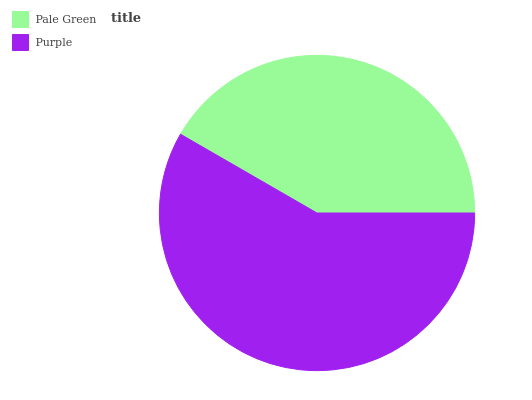Is Pale Green the minimum?
Answer yes or no. Yes. Is Purple the maximum?
Answer yes or no. Yes. Is Purple the minimum?
Answer yes or no. No. Is Purple greater than Pale Green?
Answer yes or no. Yes. Is Pale Green less than Purple?
Answer yes or no. Yes. Is Pale Green greater than Purple?
Answer yes or no. No. Is Purple less than Pale Green?
Answer yes or no. No. Is Purple the high median?
Answer yes or no. Yes. Is Pale Green the low median?
Answer yes or no. Yes. Is Pale Green the high median?
Answer yes or no. No. Is Purple the low median?
Answer yes or no. No. 